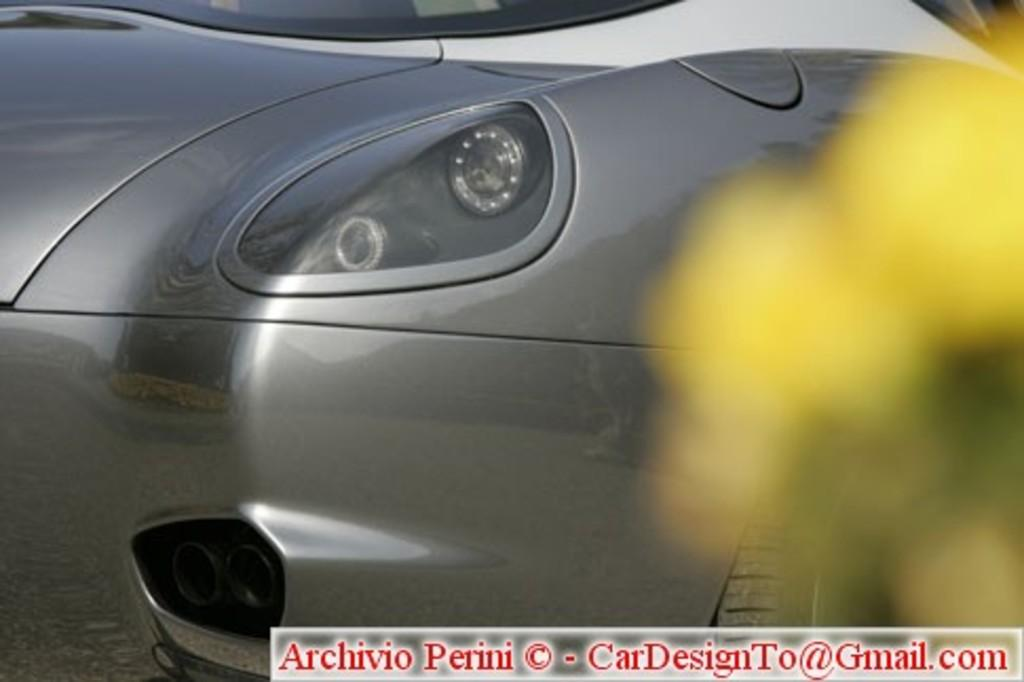What is the main subject of the image? There is a car in the image. Is there any text present in the image? Yes, there is some text at the bottom of the image. Can you describe the condition of the right side of the image? The right side of the image is blurred. How many geese are flying in the image? There are no geese present in the image. What color are the eyes of the car in the image? Cars do not have eyes, so this question cannot be answered. 